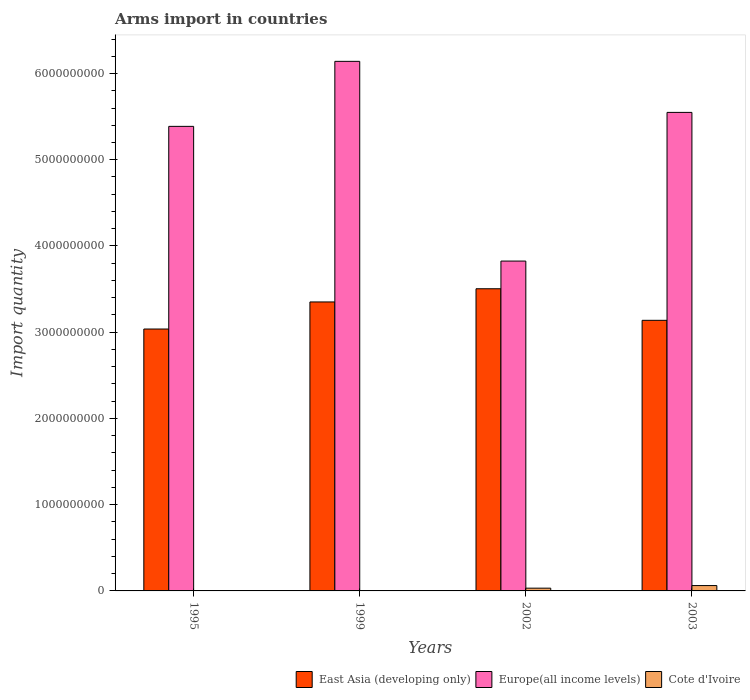Are the number of bars per tick equal to the number of legend labels?
Your answer should be compact. Yes. How many bars are there on the 2nd tick from the left?
Your response must be concise. 3. How many bars are there on the 3rd tick from the right?
Ensure brevity in your answer.  3. What is the total arms import in Europe(all income levels) in 2003?
Your answer should be compact. 5.55e+09. Across all years, what is the maximum total arms import in Cote d'Ivoire?
Provide a short and direct response. 6.20e+07. In which year was the total arms import in East Asia (developing only) minimum?
Give a very brief answer. 1995. What is the total total arms import in Europe(all income levels) in the graph?
Keep it short and to the point. 2.09e+1. What is the difference between the total arms import in Cote d'Ivoire in 1995 and that in 2002?
Your answer should be compact. -3.00e+07. What is the difference between the total arms import in Cote d'Ivoire in 2002 and the total arms import in East Asia (developing only) in 1995?
Make the answer very short. -3.00e+09. What is the average total arms import in Europe(all income levels) per year?
Your answer should be very brief. 5.23e+09. In the year 2003, what is the difference between the total arms import in Cote d'Ivoire and total arms import in Europe(all income levels)?
Ensure brevity in your answer.  -5.49e+09. In how many years, is the total arms import in Europe(all income levels) greater than 5200000000?
Offer a very short reply. 3. What is the ratio of the total arms import in Europe(all income levels) in 1995 to that in 1999?
Your answer should be very brief. 0.88. What is the difference between the highest and the second highest total arms import in Cote d'Ivoire?
Offer a terse response. 3.00e+07. What is the difference between the highest and the lowest total arms import in Europe(all income levels)?
Give a very brief answer. 2.32e+09. What does the 3rd bar from the left in 2003 represents?
Keep it short and to the point. Cote d'Ivoire. What does the 2nd bar from the right in 2003 represents?
Make the answer very short. Europe(all income levels). Is it the case that in every year, the sum of the total arms import in Cote d'Ivoire and total arms import in Europe(all income levels) is greater than the total arms import in East Asia (developing only)?
Provide a short and direct response. Yes. How many bars are there?
Offer a terse response. 12. How many years are there in the graph?
Your response must be concise. 4. Does the graph contain any zero values?
Ensure brevity in your answer.  No. What is the title of the graph?
Give a very brief answer. Arms import in countries. What is the label or title of the Y-axis?
Make the answer very short. Import quantity. What is the Import quantity in East Asia (developing only) in 1995?
Offer a terse response. 3.04e+09. What is the Import quantity of Europe(all income levels) in 1995?
Offer a terse response. 5.39e+09. What is the Import quantity in Cote d'Ivoire in 1995?
Your answer should be very brief. 2.00e+06. What is the Import quantity of East Asia (developing only) in 1999?
Offer a very short reply. 3.35e+09. What is the Import quantity in Europe(all income levels) in 1999?
Keep it short and to the point. 6.14e+09. What is the Import quantity in Cote d'Ivoire in 1999?
Provide a succinct answer. 2.00e+06. What is the Import quantity in East Asia (developing only) in 2002?
Your answer should be compact. 3.50e+09. What is the Import quantity in Europe(all income levels) in 2002?
Your response must be concise. 3.82e+09. What is the Import quantity in Cote d'Ivoire in 2002?
Give a very brief answer. 3.20e+07. What is the Import quantity in East Asia (developing only) in 2003?
Your answer should be very brief. 3.14e+09. What is the Import quantity in Europe(all income levels) in 2003?
Ensure brevity in your answer.  5.55e+09. What is the Import quantity of Cote d'Ivoire in 2003?
Keep it short and to the point. 6.20e+07. Across all years, what is the maximum Import quantity of East Asia (developing only)?
Offer a very short reply. 3.50e+09. Across all years, what is the maximum Import quantity in Europe(all income levels)?
Your answer should be very brief. 6.14e+09. Across all years, what is the maximum Import quantity of Cote d'Ivoire?
Provide a short and direct response. 6.20e+07. Across all years, what is the minimum Import quantity in East Asia (developing only)?
Provide a short and direct response. 3.04e+09. Across all years, what is the minimum Import quantity of Europe(all income levels)?
Your answer should be compact. 3.82e+09. Across all years, what is the minimum Import quantity of Cote d'Ivoire?
Offer a terse response. 2.00e+06. What is the total Import quantity in East Asia (developing only) in the graph?
Make the answer very short. 1.30e+1. What is the total Import quantity of Europe(all income levels) in the graph?
Your response must be concise. 2.09e+1. What is the total Import quantity of Cote d'Ivoire in the graph?
Your answer should be compact. 9.80e+07. What is the difference between the Import quantity in East Asia (developing only) in 1995 and that in 1999?
Your answer should be compact. -3.14e+08. What is the difference between the Import quantity in Europe(all income levels) in 1995 and that in 1999?
Offer a terse response. -7.54e+08. What is the difference between the Import quantity in Cote d'Ivoire in 1995 and that in 1999?
Your response must be concise. 0. What is the difference between the Import quantity in East Asia (developing only) in 1995 and that in 2002?
Give a very brief answer. -4.67e+08. What is the difference between the Import quantity in Europe(all income levels) in 1995 and that in 2002?
Provide a succinct answer. 1.56e+09. What is the difference between the Import quantity in Cote d'Ivoire in 1995 and that in 2002?
Provide a succinct answer. -3.00e+07. What is the difference between the Import quantity of East Asia (developing only) in 1995 and that in 2003?
Your answer should be very brief. -1.01e+08. What is the difference between the Import quantity of Europe(all income levels) in 1995 and that in 2003?
Keep it short and to the point. -1.62e+08. What is the difference between the Import quantity in Cote d'Ivoire in 1995 and that in 2003?
Offer a very short reply. -6.00e+07. What is the difference between the Import quantity of East Asia (developing only) in 1999 and that in 2002?
Give a very brief answer. -1.53e+08. What is the difference between the Import quantity in Europe(all income levels) in 1999 and that in 2002?
Provide a succinct answer. 2.32e+09. What is the difference between the Import quantity of Cote d'Ivoire in 1999 and that in 2002?
Offer a terse response. -3.00e+07. What is the difference between the Import quantity in East Asia (developing only) in 1999 and that in 2003?
Offer a terse response. 2.13e+08. What is the difference between the Import quantity in Europe(all income levels) in 1999 and that in 2003?
Ensure brevity in your answer.  5.92e+08. What is the difference between the Import quantity of Cote d'Ivoire in 1999 and that in 2003?
Provide a short and direct response. -6.00e+07. What is the difference between the Import quantity of East Asia (developing only) in 2002 and that in 2003?
Give a very brief answer. 3.66e+08. What is the difference between the Import quantity of Europe(all income levels) in 2002 and that in 2003?
Provide a succinct answer. -1.72e+09. What is the difference between the Import quantity in Cote d'Ivoire in 2002 and that in 2003?
Offer a very short reply. -3.00e+07. What is the difference between the Import quantity in East Asia (developing only) in 1995 and the Import quantity in Europe(all income levels) in 1999?
Keep it short and to the point. -3.10e+09. What is the difference between the Import quantity of East Asia (developing only) in 1995 and the Import quantity of Cote d'Ivoire in 1999?
Provide a succinct answer. 3.04e+09. What is the difference between the Import quantity of Europe(all income levels) in 1995 and the Import quantity of Cote d'Ivoire in 1999?
Make the answer very short. 5.38e+09. What is the difference between the Import quantity of East Asia (developing only) in 1995 and the Import quantity of Europe(all income levels) in 2002?
Make the answer very short. -7.88e+08. What is the difference between the Import quantity in East Asia (developing only) in 1995 and the Import quantity in Cote d'Ivoire in 2002?
Your response must be concise. 3.00e+09. What is the difference between the Import quantity in Europe(all income levels) in 1995 and the Import quantity in Cote d'Ivoire in 2002?
Ensure brevity in your answer.  5.36e+09. What is the difference between the Import quantity of East Asia (developing only) in 1995 and the Import quantity of Europe(all income levels) in 2003?
Make the answer very short. -2.51e+09. What is the difference between the Import quantity of East Asia (developing only) in 1995 and the Import quantity of Cote d'Ivoire in 2003?
Ensure brevity in your answer.  2.98e+09. What is the difference between the Import quantity in Europe(all income levels) in 1995 and the Import quantity in Cote d'Ivoire in 2003?
Offer a terse response. 5.32e+09. What is the difference between the Import quantity in East Asia (developing only) in 1999 and the Import quantity in Europe(all income levels) in 2002?
Your answer should be very brief. -4.74e+08. What is the difference between the Import quantity of East Asia (developing only) in 1999 and the Import quantity of Cote d'Ivoire in 2002?
Provide a short and direct response. 3.32e+09. What is the difference between the Import quantity in Europe(all income levels) in 1999 and the Import quantity in Cote d'Ivoire in 2002?
Make the answer very short. 6.11e+09. What is the difference between the Import quantity of East Asia (developing only) in 1999 and the Import quantity of Europe(all income levels) in 2003?
Offer a very short reply. -2.20e+09. What is the difference between the Import quantity in East Asia (developing only) in 1999 and the Import quantity in Cote d'Ivoire in 2003?
Offer a terse response. 3.29e+09. What is the difference between the Import quantity in Europe(all income levels) in 1999 and the Import quantity in Cote d'Ivoire in 2003?
Your response must be concise. 6.08e+09. What is the difference between the Import quantity of East Asia (developing only) in 2002 and the Import quantity of Europe(all income levels) in 2003?
Make the answer very short. -2.04e+09. What is the difference between the Import quantity in East Asia (developing only) in 2002 and the Import quantity in Cote d'Ivoire in 2003?
Offer a very short reply. 3.44e+09. What is the difference between the Import quantity of Europe(all income levels) in 2002 and the Import quantity of Cote d'Ivoire in 2003?
Keep it short and to the point. 3.76e+09. What is the average Import quantity in East Asia (developing only) per year?
Ensure brevity in your answer.  3.26e+09. What is the average Import quantity of Europe(all income levels) per year?
Your answer should be compact. 5.23e+09. What is the average Import quantity of Cote d'Ivoire per year?
Offer a very short reply. 2.45e+07. In the year 1995, what is the difference between the Import quantity of East Asia (developing only) and Import quantity of Europe(all income levels)?
Provide a succinct answer. -2.35e+09. In the year 1995, what is the difference between the Import quantity of East Asia (developing only) and Import quantity of Cote d'Ivoire?
Give a very brief answer. 3.04e+09. In the year 1995, what is the difference between the Import quantity in Europe(all income levels) and Import quantity in Cote d'Ivoire?
Provide a succinct answer. 5.38e+09. In the year 1999, what is the difference between the Import quantity in East Asia (developing only) and Import quantity in Europe(all income levels)?
Ensure brevity in your answer.  -2.79e+09. In the year 1999, what is the difference between the Import quantity in East Asia (developing only) and Import quantity in Cote d'Ivoire?
Offer a very short reply. 3.35e+09. In the year 1999, what is the difference between the Import quantity of Europe(all income levels) and Import quantity of Cote d'Ivoire?
Your response must be concise. 6.14e+09. In the year 2002, what is the difference between the Import quantity in East Asia (developing only) and Import quantity in Europe(all income levels)?
Your response must be concise. -3.21e+08. In the year 2002, what is the difference between the Import quantity of East Asia (developing only) and Import quantity of Cote d'Ivoire?
Your answer should be very brief. 3.47e+09. In the year 2002, what is the difference between the Import quantity of Europe(all income levels) and Import quantity of Cote d'Ivoire?
Offer a terse response. 3.79e+09. In the year 2003, what is the difference between the Import quantity in East Asia (developing only) and Import quantity in Europe(all income levels)?
Offer a terse response. -2.41e+09. In the year 2003, what is the difference between the Import quantity of East Asia (developing only) and Import quantity of Cote d'Ivoire?
Offer a very short reply. 3.08e+09. In the year 2003, what is the difference between the Import quantity in Europe(all income levels) and Import quantity in Cote d'Ivoire?
Make the answer very short. 5.49e+09. What is the ratio of the Import quantity in East Asia (developing only) in 1995 to that in 1999?
Provide a short and direct response. 0.91. What is the ratio of the Import quantity in Europe(all income levels) in 1995 to that in 1999?
Your answer should be compact. 0.88. What is the ratio of the Import quantity of East Asia (developing only) in 1995 to that in 2002?
Give a very brief answer. 0.87. What is the ratio of the Import quantity of Europe(all income levels) in 1995 to that in 2002?
Keep it short and to the point. 1.41. What is the ratio of the Import quantity in Cote d'Ivoire in 1995 to that in 2002?
Provide a succinct answer. 0.06. What is the ratio of the Import quantity of East Asia (developing only) in 1995 to that in 2003?
Provide a succinct answer. 0.97. What is the ratio of the Import quantity in Europe(all income levels) in 1995 to that in 2003?
Provide a succinct answer. 0.97. What is the ratio of the Import quantity in Cote d'Ivoire in 1995 to that in 2003?
Your answer should be compact. 0.03. What is the ratio of the Import quantity in East Asia (developing only) in 1999 to that in 2002?
Your response must be concise. 0.96. What is the ratio of the Import quantity in Europe(all income levels) in 1999 to that in 2002?
Your response must be concise. 1.61. What is the ratio of the Import quantity of Cote d'Ivoire in 1999 to that in 2002?
Your answer should be compact. 0.06. What is the ratio of the Import quantity in East Asia (developing only) in 1999 to that in 2003?
Your answer should be very brief. 1.07. What is the ratio of the Import quantity in Europe(all income levels) in 1999 to that in 2003?
Provide a short and direct response. 1.11. What is the ratio of the Import quantity in Cote d'Ivoire in 1999 to that in 2003?
Give a very brief answer. 0.03. What is the ratio of the Import quantity of East Asia (developing only) in 2002 to that in 2003?
Provide a succinct answer. 1.12. What is the ratio of the Import quantity in Europe(all income levels) in 2002 to that in 2003?
Your answer should be very brief. 0.69. What is the ratio of the Import quantity in Cote d'Ivoire in 2002 to that in 2003?
Offer a very short reply. 0.52. What is the difference between the highest and the second highest Import quantity of East Asia (developing only)?
Offer a terse response. 1.53e+08. What is the difference between the highest and the second highest Import quantity of Europe(all income levels)?
Provide a short and direct response. 5.92e+08. What is the difference between the highest and the second highest Import quantity in Cote d'Ivoire?
Offer a terse response. 3.00e+07. What is the difference between the highest and the lowest Import quantity of East Asia (developing only)?
Give a very brief answer. 4.67e+08. What is the difference between the highest and the lowest Import quantity in Europe(all income levels)?
Provide a short and direct response. 2.32e+09. What is the difference between the highest and the lowest Import quantity of Cote d'Ivoire?
Make the answer very short. 6.00e+07. 